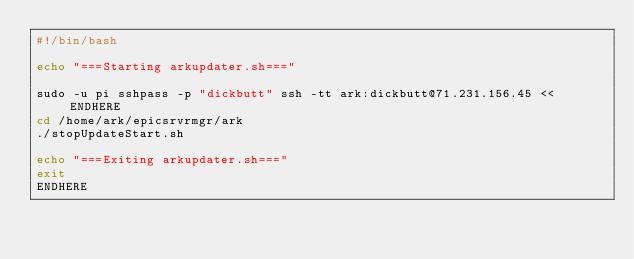Convert code to text. <code><loc_0><loc_0><loc_500><loc_500><_Bash_>#!/bin/bash

echo "===Starting arkupdater.sh==="

sudo -u pi sshpass -p "dickbutt" ssh -tt ark:dickbutt@71.231.156.45 << ENDHERE
cd /home/ark/epicsrvrmgr/ark
./stopUpdateStart.sh

echo "===Exiting arkupdater.sh==="
exit
ENDHERE
</code> 